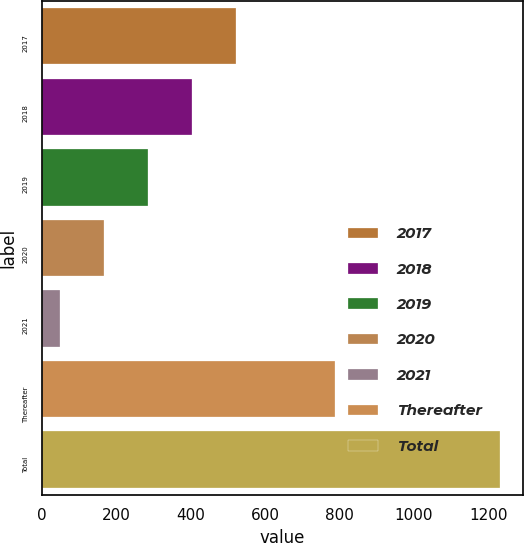Convert chart to OTSL. <chart><loc_0><loc_0><loc_500><loc_500><bar_chart><fcel>2017<fcel>2018<fcel>2019<fcel>2020<fcel>2021<fcel>Thereafter<fcel>Total<nl><fcel>522.2<fcel>403.9<fcel>285.6<fcel>167.3<fcel>49<fcel>788<fcel>1232<nl></chart> 